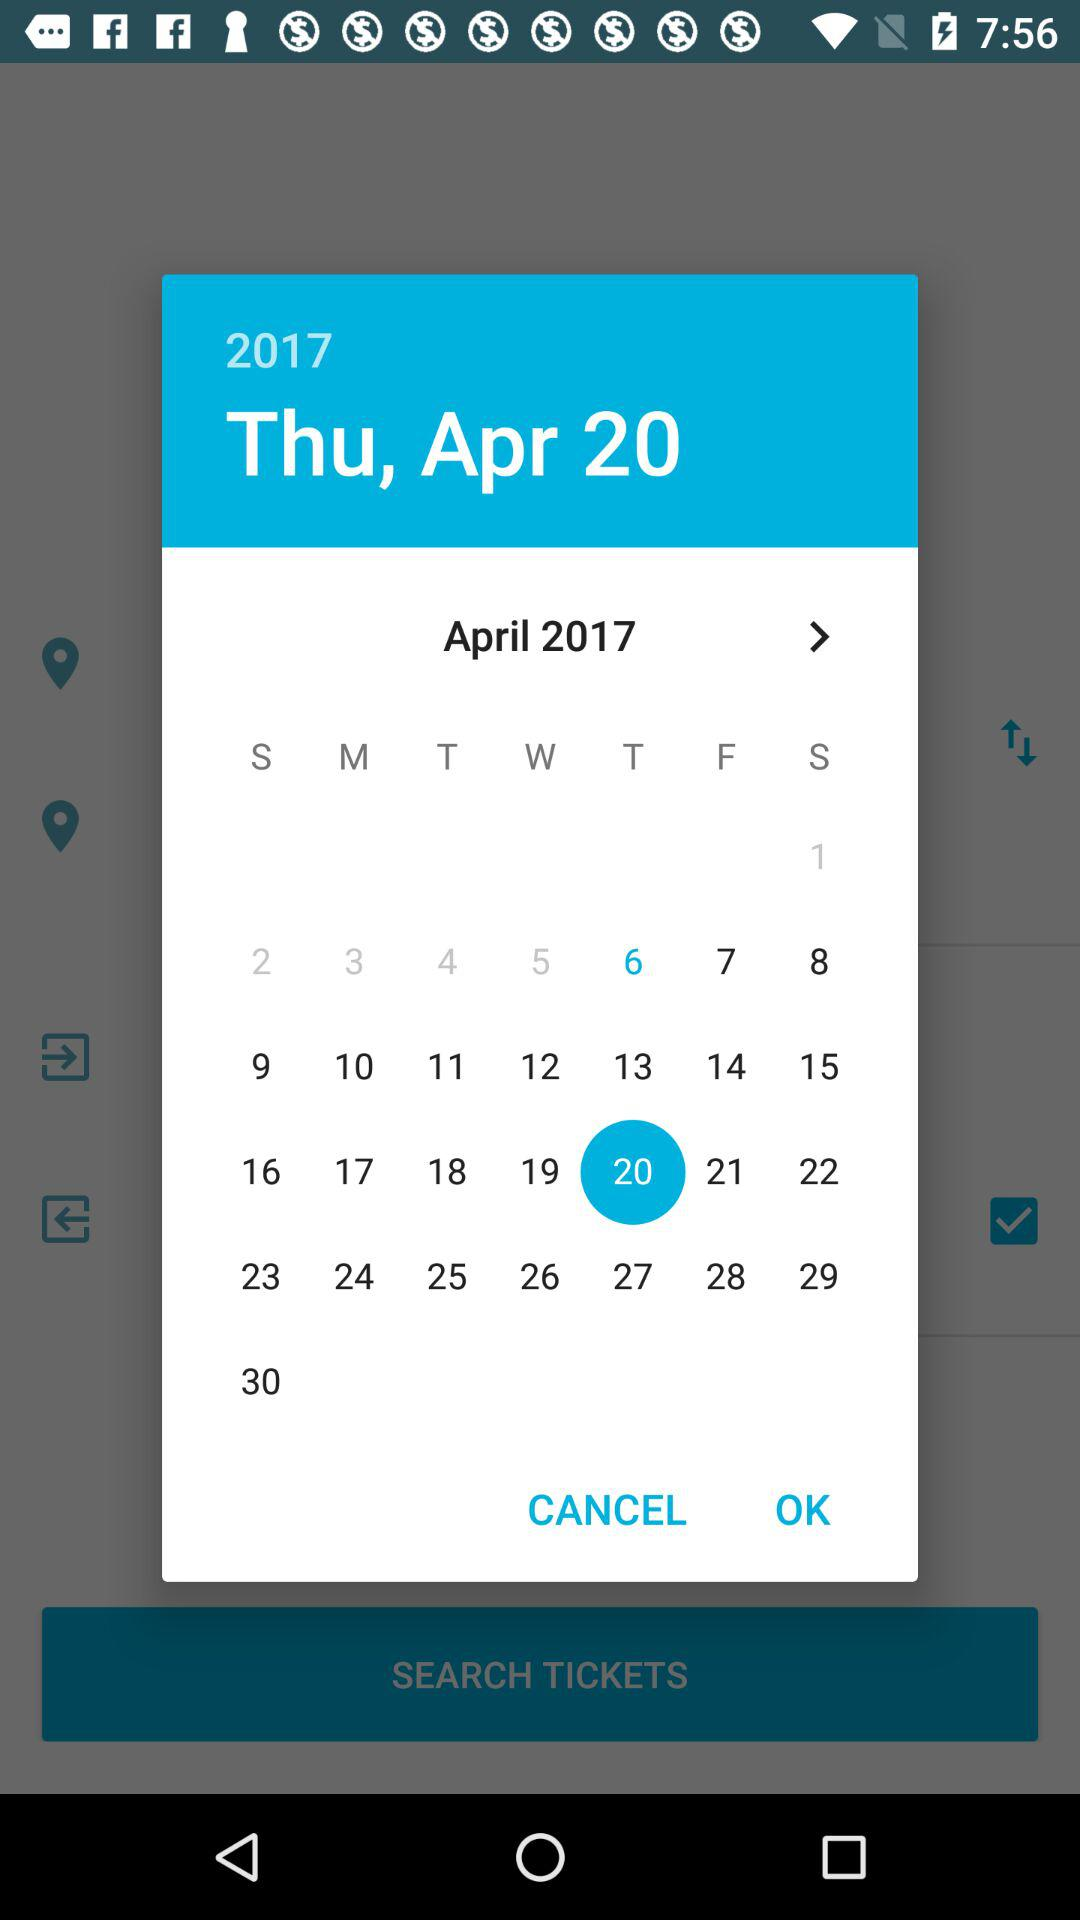What day falls on the 17th of April? The day is Monday. 